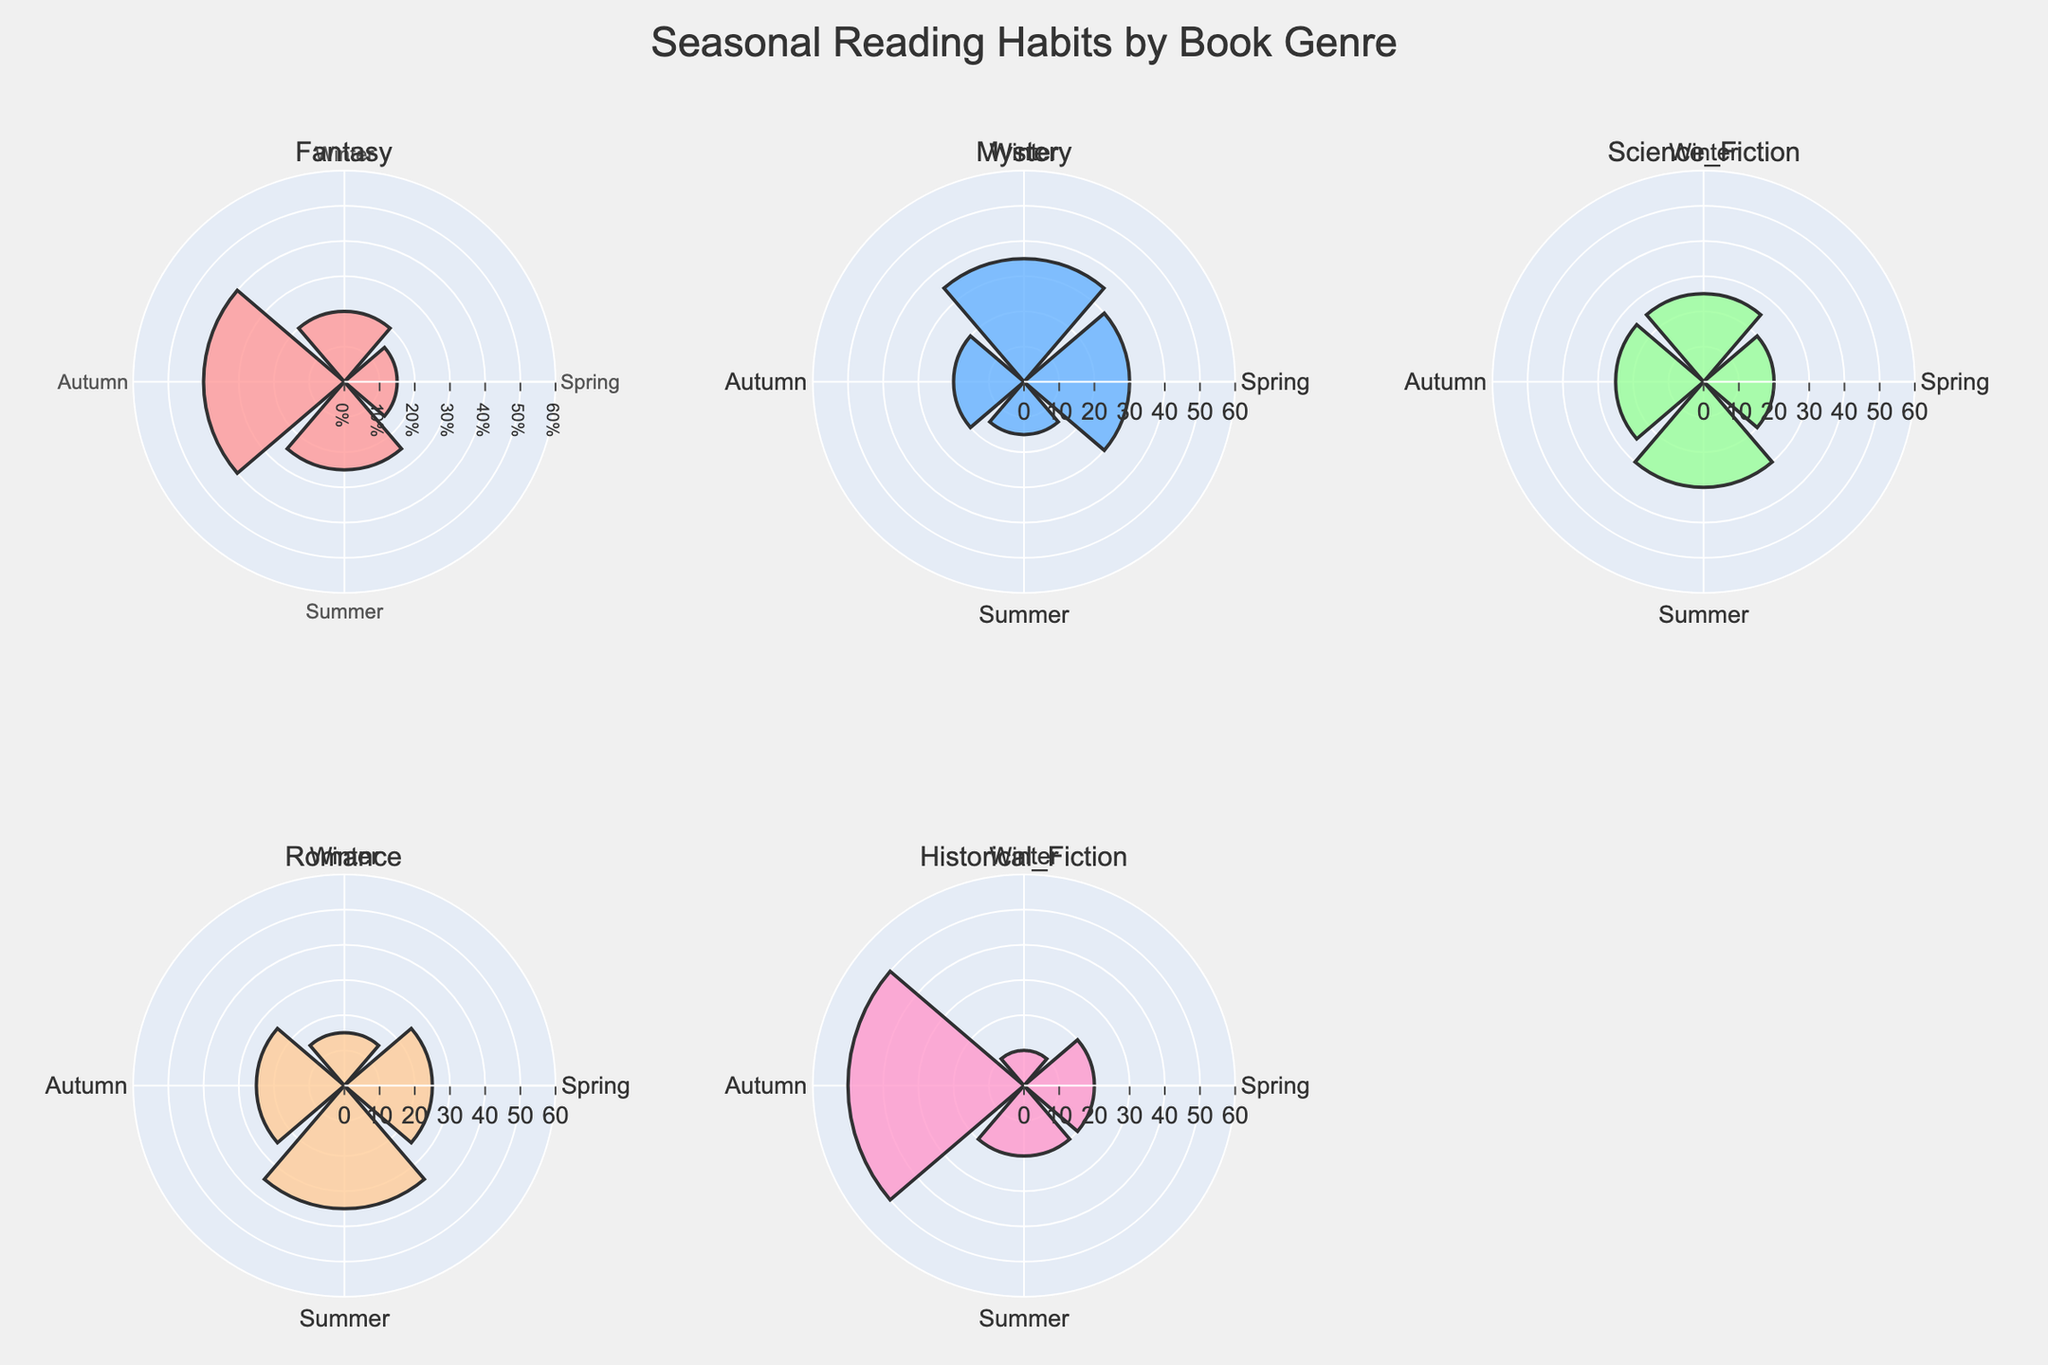What season has the highest percentage of readers for Fantasy? By looking at the Fantasy subplot, we see that the Autumn segment has the longest bar, indicating the highest percentage.
Answer: Autumn Which book genre has the highest percentage of readers in Winter? In the Winter segments of all subplots, Mystery shows the tallest bar, indicating the highest percentage.
Answer: Mystery What is the total percentage of readers in Autumn for Science Fiction and Romance combined? Science Fiction in Autumn has 25%, and Romance has 25% in Autumn. Adding these together, 25% + 25% = 50%.
Answer: 50% Which season has the least preference for readers of Historical Fiction? In the Historical Fiction subplot, the Winter segment is the shortest, indicating the least preference.
Answer: Winter Compare the readership percentage in Summer between Mystery and Romance. Which one has more readers? In the Summer segments, Mystery has 15%, while Romance has 35%. Romance has more readers.
Answer: Romance How does the Summer percentage for Fantasy compare to that of Science Fiction? Fantasy has 25% in Summer, while Science Fiction has 30%. Science Fiction has a higher Summer percentage.
Answer: Science Fiction What is the average percentage of readers for Romance across all seasons? The percentages for Romance are 15%, 25%, 35%, and 25%. The average is (15 + 25 + 35 + 25) / 4 = 25%.
Answer: 25% Which genre shows the most significant variation in reader percentages across seasons? Historical Fiction has drastic changes with 10% in Winter and 50% in Autumn, showing significant variation.
Answer: Historical Fiction In which season is the readership of Science Fiction equal to the readership of Historical Fiction? Both Science Fiction and Historical Fiction have a 20% readership in Spring.
Answer: Spring 